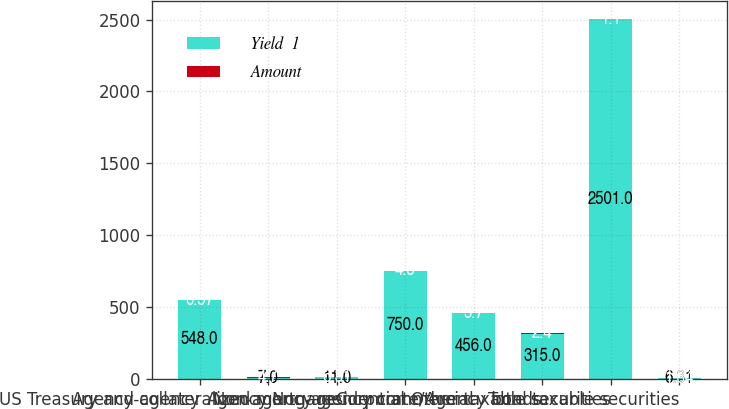Convert chart. <chart><loc_0><loc_0><loc_500><loc_500><stacked_bar_chart><ecel><fcel>US Treasury and agency<fcel>Agency<fcel>Agency-collateralized mortgage<fcel>Non-agency residential<fcel>Non-agency commercial<fcel>Corporate/Agency bonds<fcel>Other taxable securities<fcel>Total taxable securities<nl><fcel>Yield  1<fcel>548<fcel>7<fcel>11<fcel>750<fcel>456<fcel>315<fcel>2501<fcel>6.31<nl><fcel>Amount<fcel>0.57<fcel>4.7<fcel>6.31<fcel>4.5<fcel>5.7<fcel>2.4<fcel>1.1<fcel>1.84<nl></chart> 